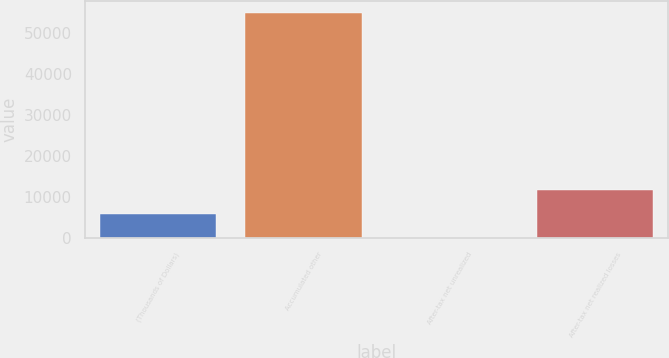Convert chart. <chart><loc_0><loc_0><loc_500><loc_500><bar_chart><fcel>(Thousands of Dollars)<fcel>Accumulated other<fcel>After-tax net unrealized<fcel>After-tax net realized losses<nl><fcel>5825.8<fcel>54862<fcel>70<fcel>11581.6<nl></chart> 